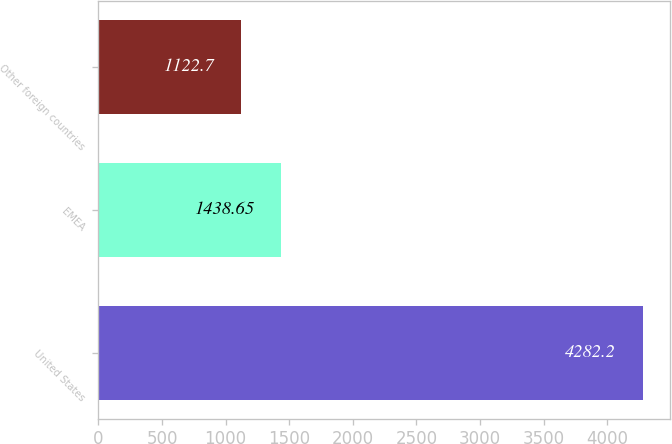Convert chart. <chart><loc_0><loc_0><loc_500><loc_500><bar_chart><fcel>United States<fcel>EMEA<fcel>Other foreign countries<nl><fcel>4282.2<fcel>1438.65<fcel>1122.7<nl></chart> 